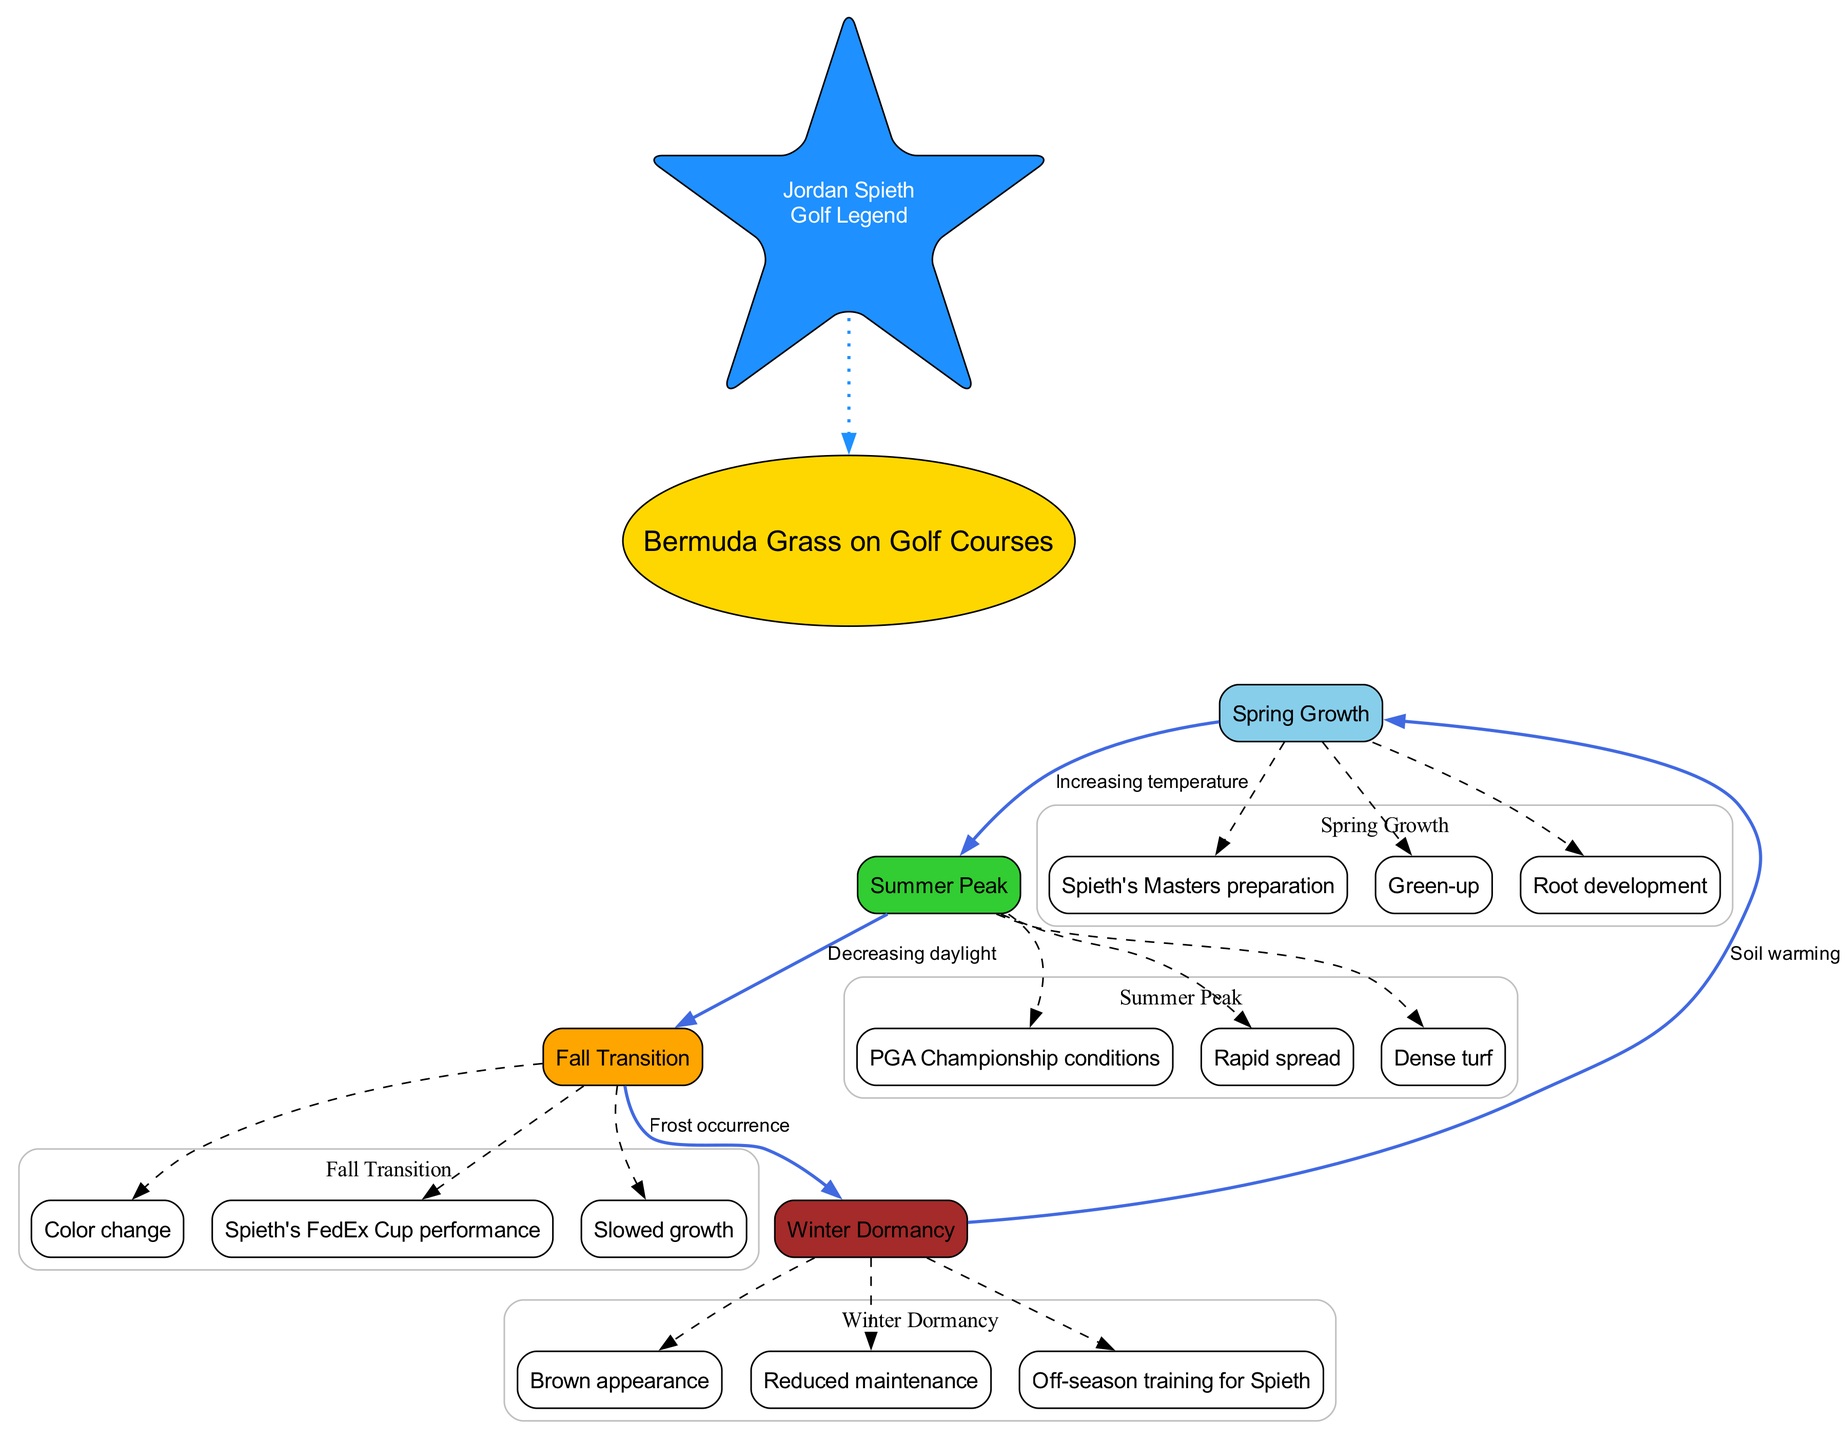What are the main nodes in the lifecycle of Bermuda grass? The main nodes listed in the diagram are Spring Growth, Summer Peak, Fall Transition, and Winter Dormancy. These nodes represent the four key phases in the growth cycle of Bermuda grass.
Answer: Spring Growth, Summer Peak, Fall Transition, Winter Dormancy How many sub-nodes are connected to Summer Peak? The diagram specifies that there are three sub-nodes connected to the Summer Peak, which are Rapid spread, Dense turf, and PGA Championship conditions.
Answer: 3 What seasonal factor leads from Spring Growth to Summer Peak? The diagram indicates that "Increasing temperature" is the seasonal factor that connects Spring Growth to Summer Peak by promoting the rapid growth of Bermuda grass.
Answer: Increasing temperature Which sub-node is related to Spieth's Masters preparation? The diagram shows that the sub-node "Spieth's Masters preparation" is associated with the Spring Growth phase, indicating a preparation period for Jordan Spieth for the tournament.
Answer: Spieth's Masters preparation What color represents Winter Dormancy in the diagram? In the visual representation, Winter Dormancy is assigned a color of brown, which corresponds to its characteristic brown appearance during the dormancy phase.
Answer: Brown Explain the transition from Fall Transition to Winter Dormancy. The diagram illustrates that the transition from Fall Transition to Winter Dormancy is affected by the occurrence of frost. As temperatures drop and frost occurs, Bermuda grass enters into dormancy because growing conditions become unfavorable.
Answer: Frost occurrence Which event does the Summer Peak sub-node "Dense turf" correlate with? The sub-node "Dense turf" under Summer Peak is correlated with favorable playing conditions experienced during the PGA Championship, indicating that this phase promotes a thick and lush playing surface.
Answer: PGA Championship conditions How does Winter Dormancy cycle back to Spring Growth? The diagram highlights that the movement from Winter Dormancy back to Spring Growth is initiated by the warming of the soil, which signifies the approach of spring and the restart of growth cycles.
Answer: Soil warming 